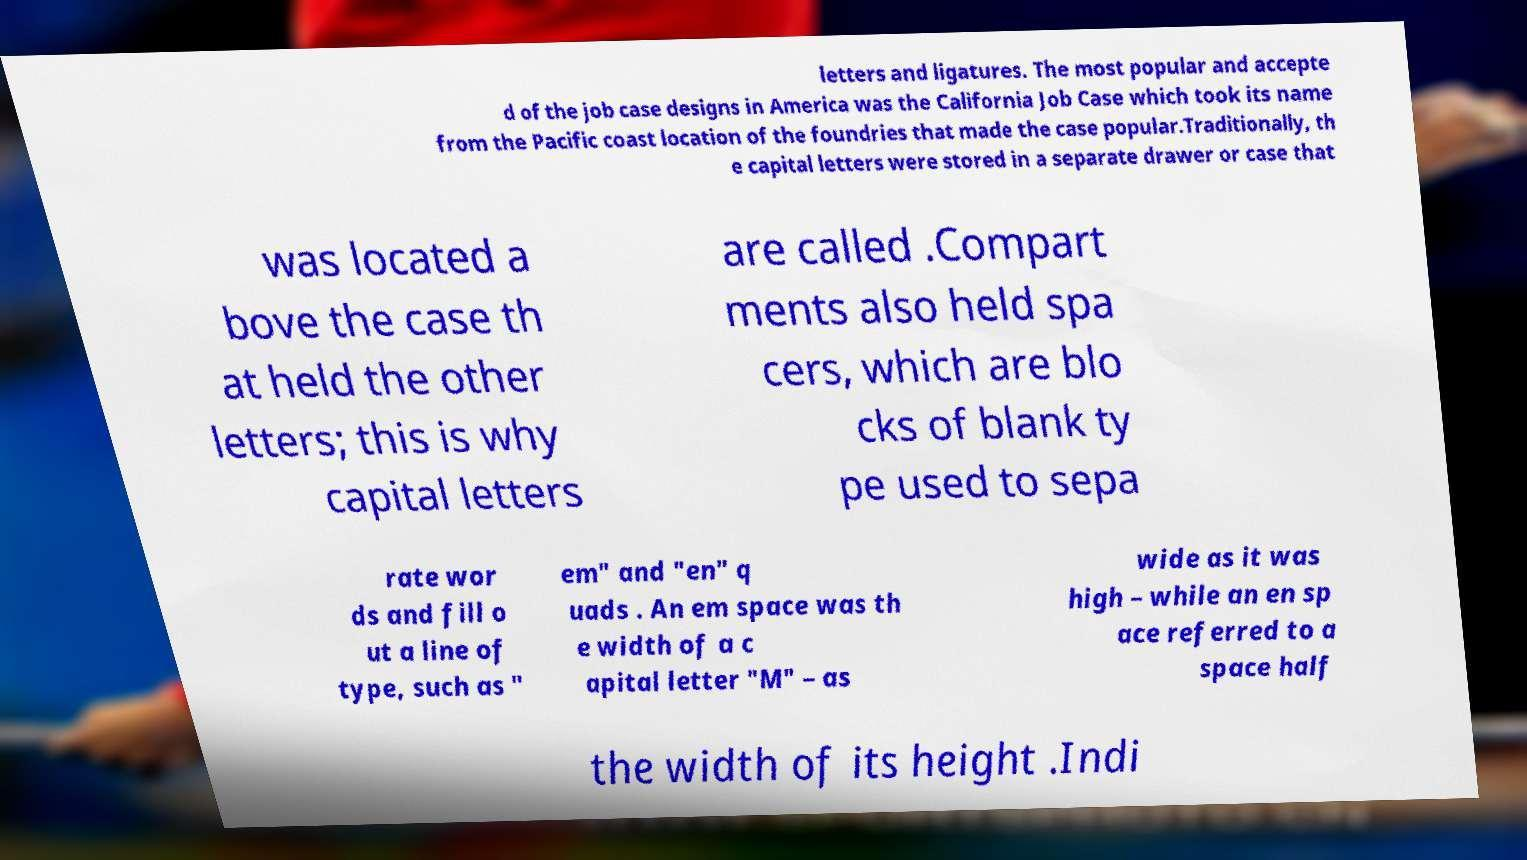Please read and relay the text visible in this image. What does it say? letters and ligatures. The most popular and accepte d of the job case designs in America was the California Job Case which took its name from the Pacific coast location of the foundries that made the case popular.Traditionally, th e capital letters were stored in a separate drawer or case that was located a bove the case th at held the other letters; this is why capital letters are called .Compart ments also held spa cers, which are blo cks of blank ty pe used to sepa rate wor ds and fill o ut a line of type, such as " em" and "en" q uads . An em space was th e width of a c apital letter "M" – as wide as it was high – while an en sp ace referred to a space half the width of its height .Indi 